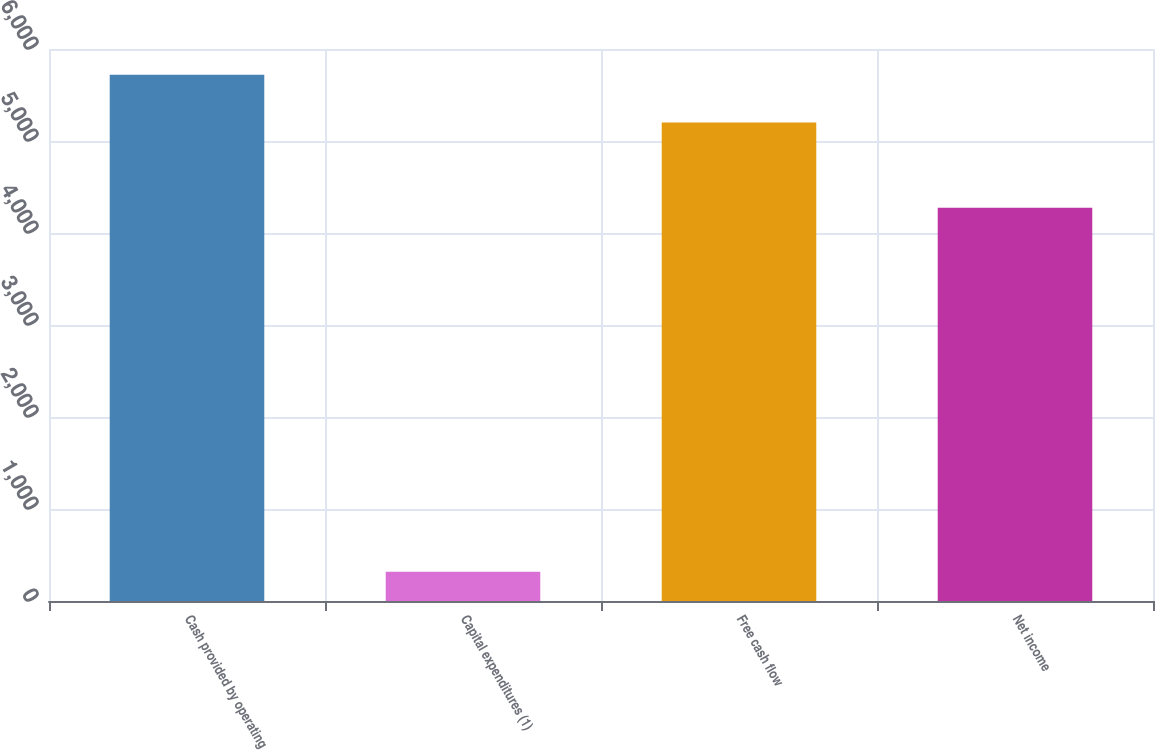Convert chart to OTSL. <chart><loc_0><loc_0><loc_500><loc_500><bar_chart><fcel>Cash provided by operating<fcel>Capital expenditures (1)<fcel>Free cash flow<fcel>Net income<nl><fcel>5721.1<fcel>319<fcel>5201<fcel>4274<nl></chart> 